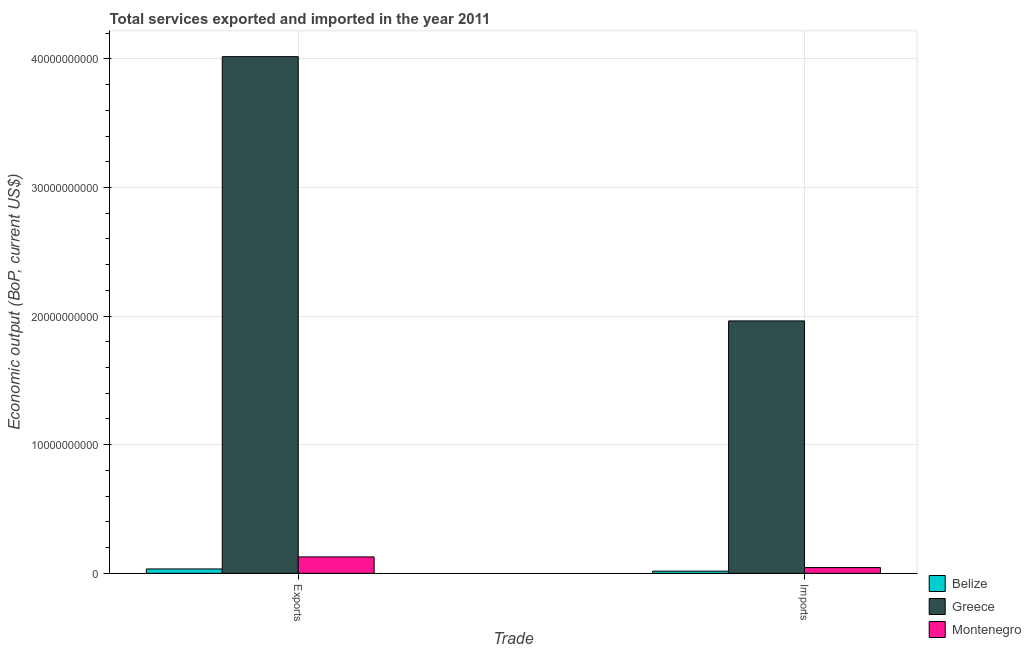How many groups of bars are there?
Your answer should be very brief. 2. Are the number of bars per tick equal to the number of legend labels?
Give a very brief answer. Yes. How many bars are there on the 1st tick from the right?
Your response must be concise. 3. What is the label of the 2nd group of bars from the left?
Keep it short and to the point. Imports. What is the amount of service exports in Belize?
Make the answer very short. 3.40e+08. Across all countries, what is the maximum amount of service imports?
Keep it short and to the point. 1.96e+1. Across all countries, what is the minimum amount of service imports?
Provide a short and direct response. 1.71e+08. In which country was the amount of service exports maximum?
Ensure brevity in your answer.  Greece. In which country was the amount of service exports minimum?
Offer a terse response. Belize. What is the total amount of service imports in the graph?
Your answer should be compact. 2.02e+1. What is the difference between the amount of service exports in Belize and that in Greece?
Keep it short and to the point. -3.98e+1. What is the difference between the amount of service imports in Montenegro and the amount of service exports in Greece?
Offer a very short reply. -3.97e+1. What is the average amount of service imports per country?
Keep it short and to the point. 6.75e+09. What is the difference between the amount of service exports and amount of service imports in Belize?
Keep it short and to the point. 1.69e+08. What is the ratio of the amount of service imports in Belize to that in Greece?
Give a very brief answer. 0.01. In how many countries, is the amount of service exports greater than the average amount of service exports taken over all countries?
Ensure brevity in your answer.  1. What does the 3rd bar from the right in Exports represents?
Make the answer very short. Belize. How many bars are there?
Provide a short and direct response. 6. How many countries are there in the graph?
Provide a succinct answer. 3. What is the difference between two consecutive major ticks on the Y-axis?
Offer a terse response. 1.00e+1. Does the graph contain grids?
Provide a short and direct response. Yes. Where does the legend appear in the graph?
Your answer should be very brief. Bottom right. How are the legend labels stacked?
Keep it short and to the point. Vertical. What is the title of the graph?
Offer a terse response. Total services exported and imported in the year 2011. Does "Macedonia" appear as one of the legend labels in the graph?
Give a very brief answer. No. What is the label or title of the X-axis?
Provide a short and direct response. Trade. What is the label or title of the Y-axis?
Provide a short and direct response. Economic output (BoP, current US$). What is the Economic output (BoP, current US$) of Belize in Exports?
Your answer should be very brief. 3.40e+08. What is the Economic output (BoP, current US$) of Greece in Exports?
Your answer should be compact. 4.02e+1. What is the Economic output (BoP, current US$) of Montenegro in Exports?
Keep it short and to the point. 1.28e+09. What is the Economic output (BoP, current US$) in Belize in Imports?
Your answer should be very brief. 1.71e+08. What is the Economic output (BoP, current US$) in Greece in Imports?
Your answer should be compact. 1.96e+1. What is the Economic output (BoP, current US$) of Montenegro in Imports?
Give a very brief answer. 4.48e+08. Across all Trade, what is the maximum Economic output (BoP, current US$) in Belize?
Give a very brief answer. 3.40e+08. Across all Trade, what is the maximum Economic output (BoP, current US$) of Greece?
Offer a very short reply. 4.02e+1. Across all Trade, what is the maximum Economic output (BoP, current US$) of Montenegro?
Offer a terse response. 1.28e+09. Across all Trade, what is the minimum Economic output (BoP, current US$) in Belize?
Give a very brief answer. 1.71e+08. Across all Trade, what is the minimum Economic output (BoP, current US$) of Greece?
Your answer should be compact. 1.96e+1. Across all Trade, what is the minimum Economic output (BoP, current US$) of Montenegro?
Your response must be concise. 4.48e+08. What is the total Economic output (BoP, current US$) in Belize in the graph?
Ensure brevity in your answer.  5.11e+08. What is the total Economic output (BoP, current US$) of Greece in the graph?
Offer a terse response. 5.98e+1. What is the total Economic output (BoP, current US$) in Montenegro in the graph?
Give a very brief answer. 1.72e+09. What is the difference between the Economic output (BoP, current US$) in Belize in Exports and that in Imports?
Offer a terse response. 1.69e+08. What is the difference between the Economic output (BoP, current US$) in Greece in Exports and that in Imports?
Ensure brevity in your answer.  2.05e+1. What is the difference between the Economic output (BoP, current US$) in Montenegro in Exports and that in Imports?
Offer a very short reply. 8.28e+08. What is the difference between the Economic output (BoP, current US$) in Belize in Exports and the Economic output (BoP, current US$) in Greece in Imports?
Ensure brevity in your answer.  -1.93e+1. What is the difference between the Economic output (BoP, current US$) in Belize in Exports and the Economic output (BoP, current US$) in Montenegro in Imports?
Your answer should be very brief. -1.07e+08. What is the difference between the Economic output (BoP, current US$) of Greece in Exports and the Economic output (BoP, current US$) of Montenegro in Imports?
Give a very brief answer. 3.97e+1. What is the average Economic output (BoP, current US$) of Belize per Trade?
Your answer should be compact. 2.56e+08. What is the average Economic output (BoP, current US$) in Greece per Trade?
Your response must be concise. 2.99e+1. What is the average Economic output (BoP, current US$) in Montenegro per Trade?
Your answer should be compact. 8.62e+08. What is the difference between the Economic output (BoP, current US$) in Belize and Economic output (BoP, current US$) in Greece in Exports?
Give a very brief answer. -3.98e+1. What is the difference between the Economic output (BoP, current US$) in Belize and Economic output (BoP, current US$) in Montenegro in Exports?
Your response must be concise. -9.36e+08. What is the difference between the Economic output (BoP, current US$) of Greece and Economic output (BoP, current US$) of Montenegro in Exports?
Offer a terse response. 3.89e+1. What is the difference between the Economic output (BoP, current US$) in Belize and Economic output (BoP, current US$) in Greece in Imports?
Make the answer very short. -1.95e+1. What is the difference between the Economic output (BoP, current US$) of Belize and Economic output (BoP, current US$) of Montenegro in Imports?
Offer a terse response. -2.77e+08. What is the difference between the Economic output (BoP, current US$) of Greece and Economic output (BoP, current US$) of Montenegro in Imports?
Your answer should be very brief. 1.92e+1. What is the ratio of the Economic output (BoP, current US$) of Belize in Exports to that in Imports?
Offer a very short reply. 1.99. What is the ratio of the Economic output (BoP, current US$) in Greece in Exports to that in Imports?
Your answer should be compact. 2.05. What is the ratio of the Economic output (BoP, current US$) in Montenegro in Exports to that in Imports?
Your response must be concise. 2.85. What is the difference between the highest and the second highest Economic output (BoP, current US$) of Belize?
Offer a very short reply. 1.69e+08. What is the difference between the highest and the second highest Economic output (BoP, current US$) in Greece?
Give a very brief answer. 2.05e+1. What is the difference between the highest and the second highest Economic output (BoP, current US$) of Montenegro?
Your answer should be very brief. 8.28e+08. What is the difference between the highest and the lowest Economic output (BoP, current US$) in Belize?
Give a very brief answer. 1.69e+08. What is the difference between the highest and the lowest Economic output (BoP, current US$) in Greece?
Provide a succinct answer. 2.05e+1. What is the difference between the highest and the lowest Economic output (BoP, current US$) of Montenegro?
Offer a terse response. 8.28e+08. 